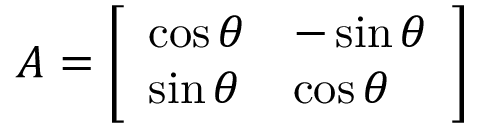Convert formula to latex. <formula><loc_0><loc_0><loc_500><loc_500>A = { \left [ \begin{array} { l l } { \cos \theta } & { - \sin \theta } \\ { \sin \theta } & { \cos \theta } \end{array} \right ] }</formula> 